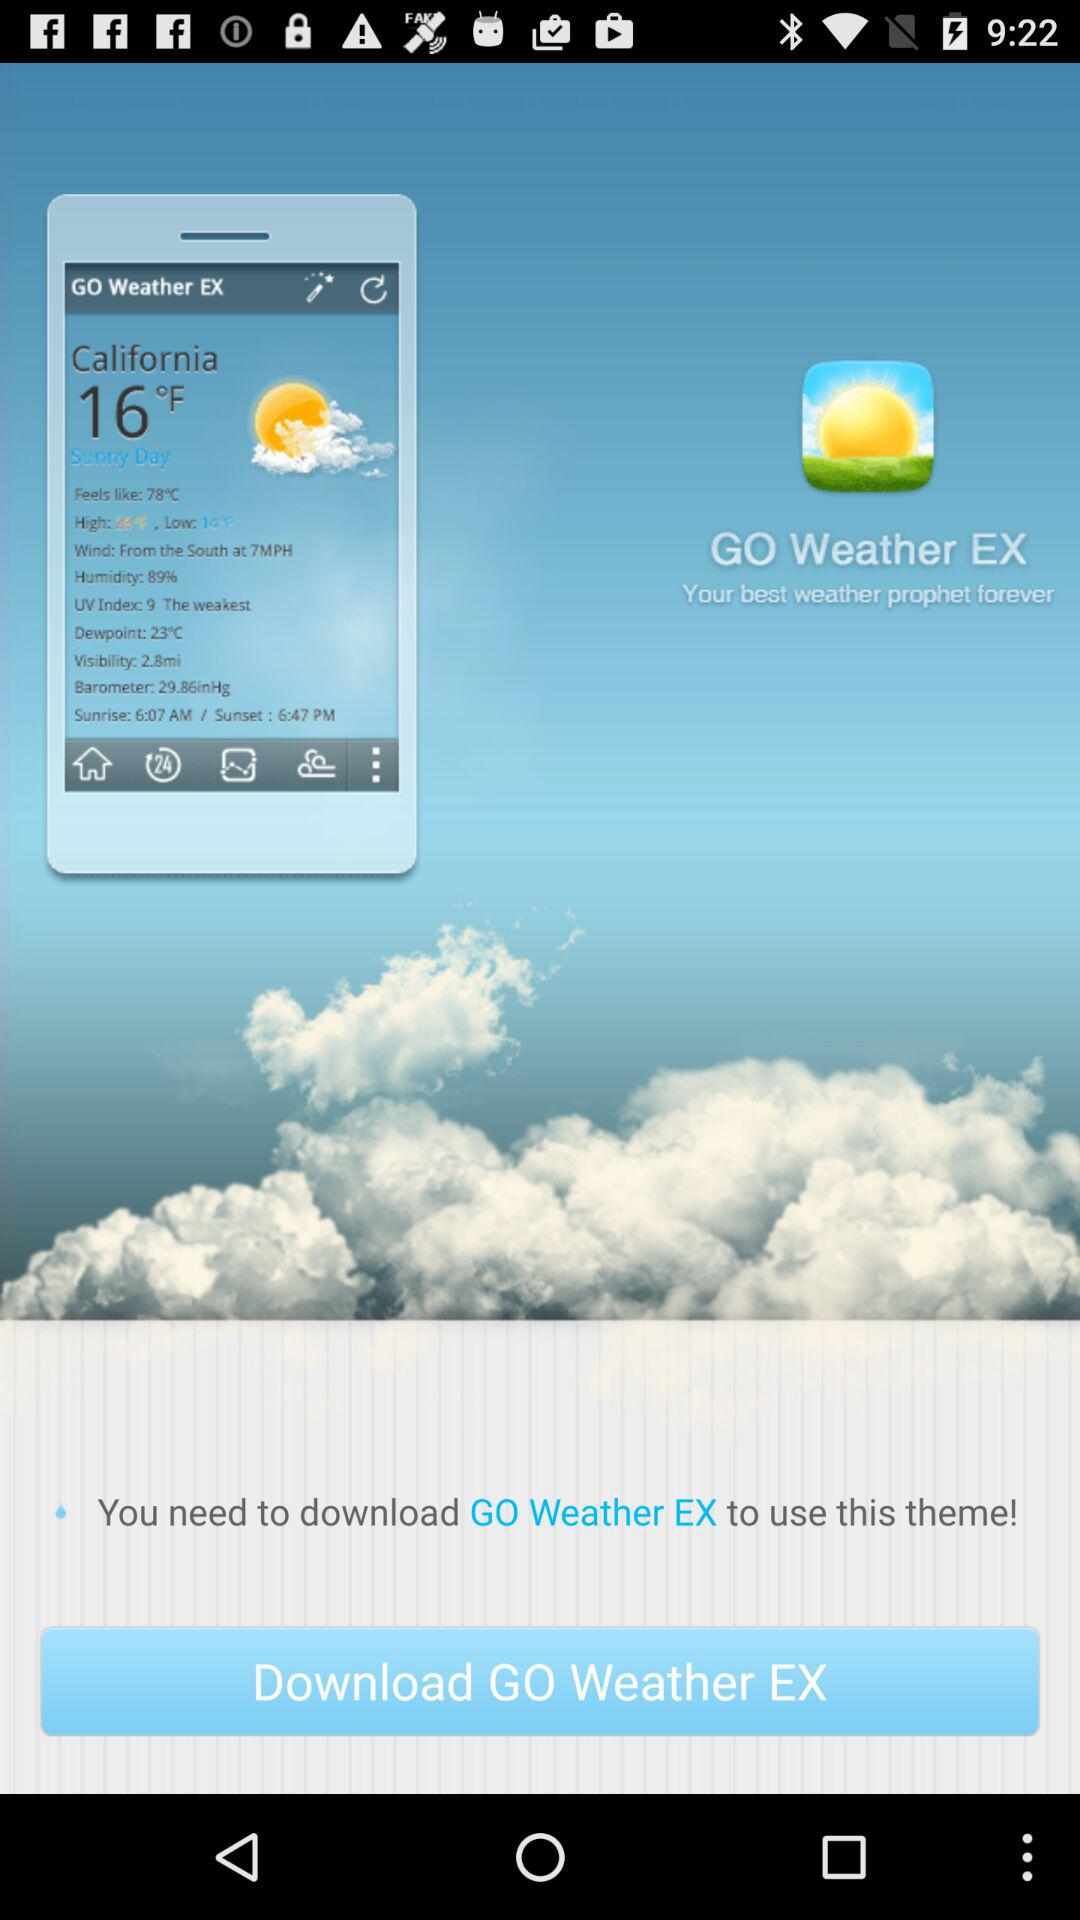What is the "Dewpoint" in California? The "Dewpoint" in California is 23°C. 